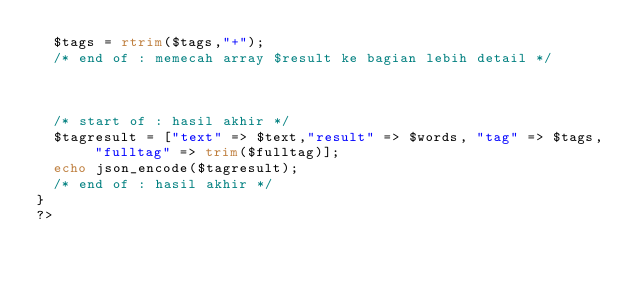<code> <loc_0><loc_0><loc_500><loc_500><_PHP_>  $tags = rtrim($tags,"+");
  /* end of : memecah array $result ke bagian lebih detail */



  /* start of : hasil akhir */
  $tagresult = ["text" => $text,"result" => $words, "tag" => $tags, "fulltag" => trim($fulltag)];
  echo json_encode($tagresult);
  /* end of : hasil akhir */
}
?>
</code> 